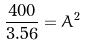Convert formula to latex. <formula><loc_0><loc_0><loc_500><loc_500>\frac { 4 0 0 } { 3 . 5 6 } = A ^ { 2 }</formula> 